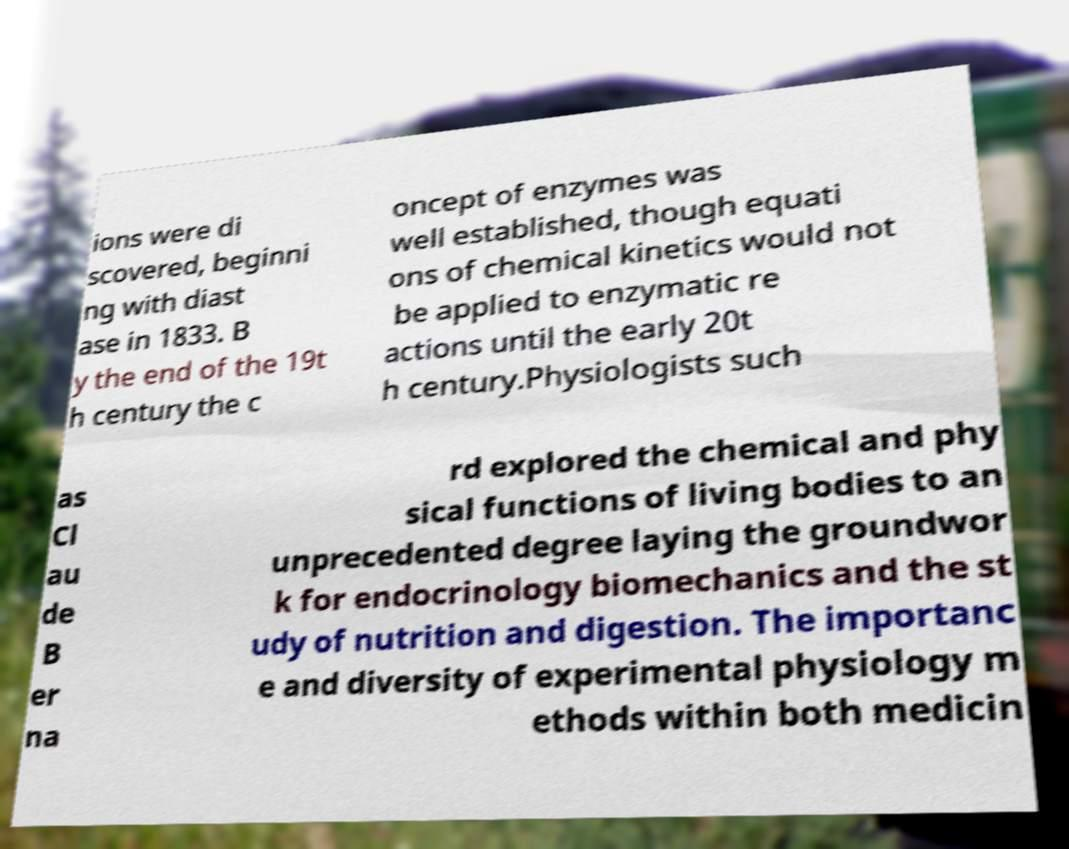What messages or text are displayed in this image? I need them in a readable, typed format. ions were di scovered, beginni ng with diast ase in 1833. B y the end of the 19t h century the c oncept of enzymes was well established, though equati ons of chemical kinetics would not be applied to enzymatic re actions until the early 20t h century.Physiologists such as Cl au de B er na rd explored the chemical and phy sical functions of living bodies to an unprecedented degree laying the groundwor k for endocrinology biomechanics and the st udy of nutrition and digestion. The importanc e and diversity of experimental physiology m ethods within both medicin 